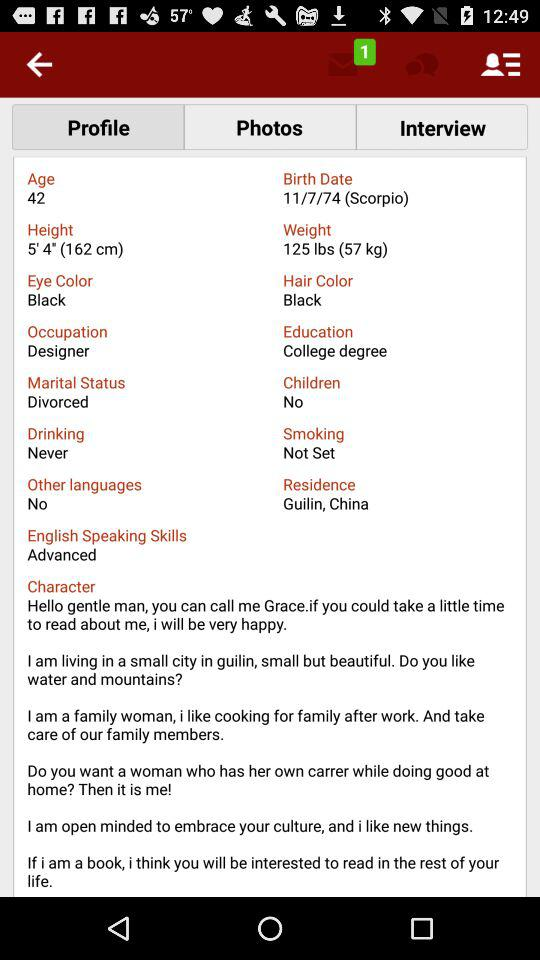What is the occupation? The user is a designer. 